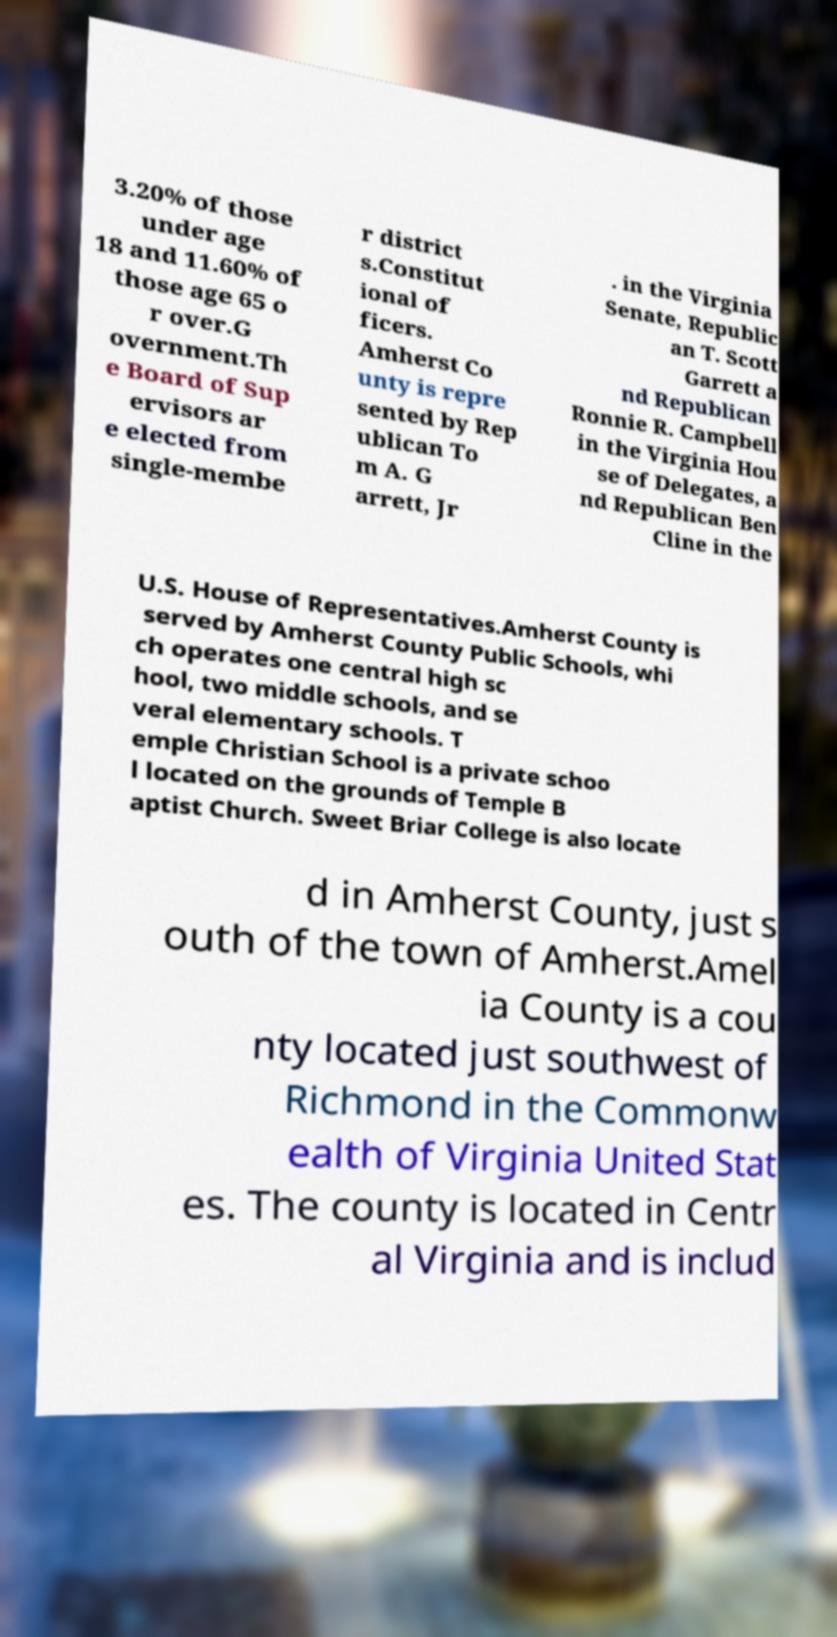Can you accurately transcribe the text from the provided image for me? 3.20% of those under age 18 and 11.60% of those age 65 o r over.G overnment.Th e Board of Sup ervisors ar e elected from single-membe r district s.Constitut ional of ficers. Amherst Co unty is repre sented by Rep ublican To m A. G arrett, Jr . in the Virginia Senate, Republic an T. Scott Garrett a nd Republican Ronnie R. Campbell in the Virginia Hou se of Delegates, a nd Republican Ben Cline in the U.S. House of Representatives.Amherst County is served by Amherst County Public Schools, whi ch operates one central high sc hool, two middle schools, and se veral elementary schools. T emple Christian School is a private schoo l located on the grounds of Temple B aptist Church. Sweet Briar College is also locate d in Amherst County, just s outh of the town of Amherst.Amel ia County is a cou nty located just southwest of Richmond in the Commonw ealth of Virginia United Stat es. The county is located in Centr al Virginia and is includ 